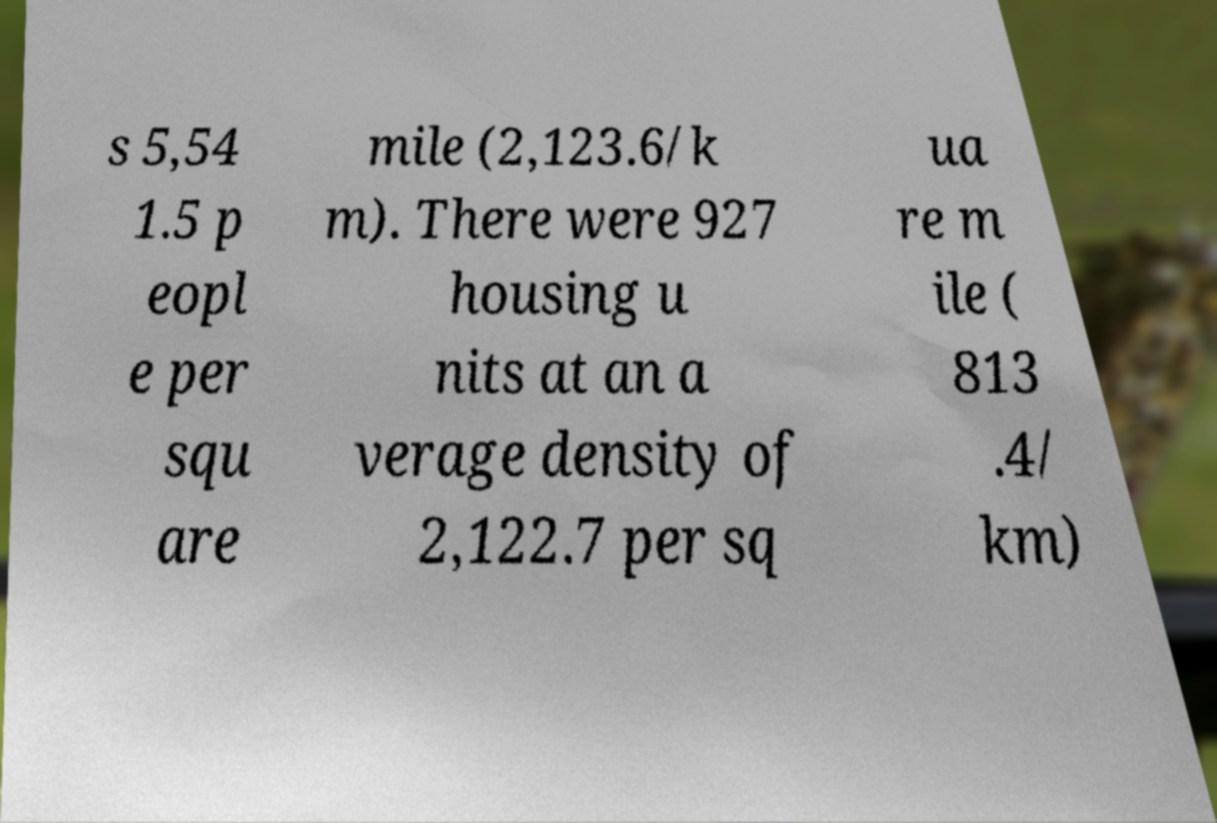Please identify and transcribe the text found in this image. s 5,54 1.5 p eopl e per squ are mile (2,123.6/k m). There were 927 housing u nits at an a verage density of 2,122.7 per sq ua re m ile ( 813 .4/ km) 